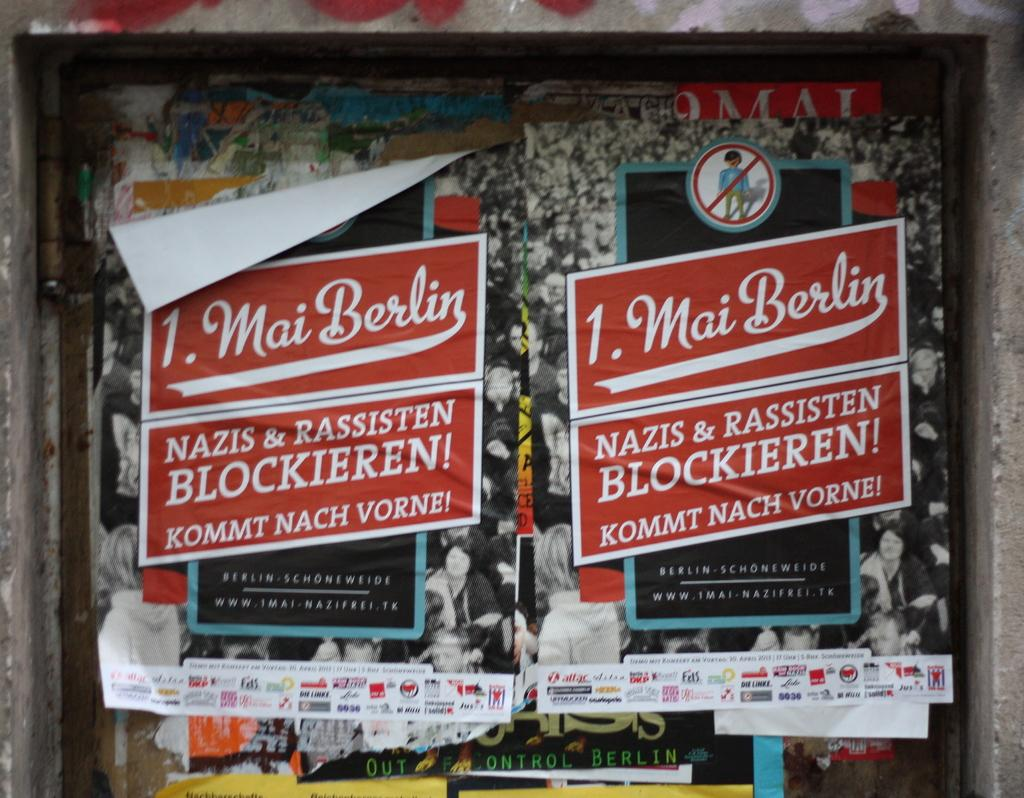What is attached to the wall in the image? There are papers attached to the wall in the image. What colors are the papers? The papers are in red and white color. What color is the background in the image? The background of the image contains a black color paper. Is there a maid wearing a stocking in the image? There is no maid or stocking present in the image; it only features papers attached to the wall in red and white colors, with a black color paper as the background. 